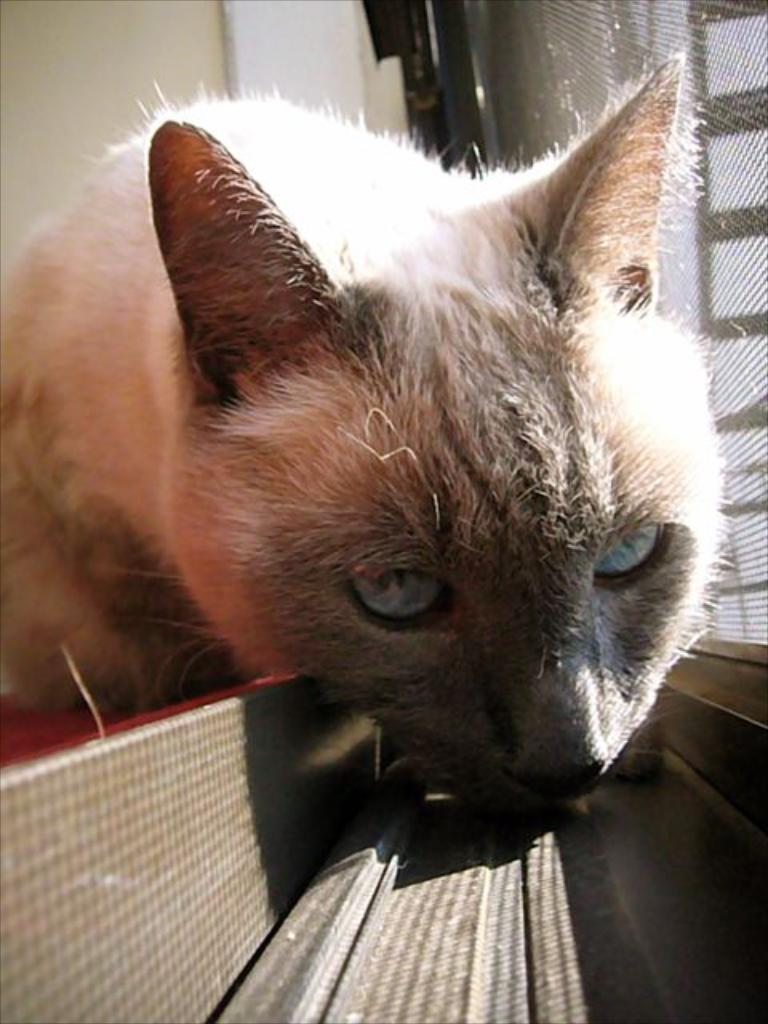What type of animal can be seen in the image? There is an animal on the surface in the image. What can be seen in the background of the image? There is a wall and a mesh in the background of the image. What type of leather is visible on the ground in the image? There is no leather visible on the ground in the image. 